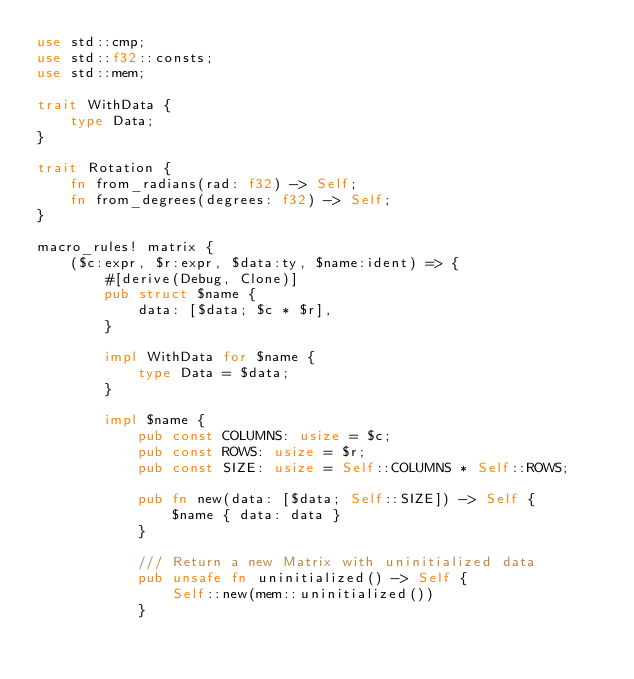<code> <loc_0><loc_0><loc_500><loc_500><_Rust_>use std::cmp;
use std::f32::consts;
use std::mem;

trait WithData {
    type Data;
}

trait Rotation {
    fn from_radians(rad: f32) -> Self;
    fn from_degrees(degrees: f32) -> Self;
}

macro_rules! matrix {
    ($c:expr, $r:expr, $data:ty, $name:ident) => {
        #[derive(Debug, Clone)]
        pub struct $name {
            data: [$data; $c * $r],
        }

        impl WithData for $name {
            type Data = $data;
        }

        impl $name {
            pub const COLUMNS: usize = $c;
            pub const ROWS: usize = $r;
            pub const SIZE: usize = Self::COLUMNS * Self::ROWS;

            pub fn new(data: [$data; Self::SIZE]) -> Self {
                $name { data: data }
            }

            /// Return a new Matrix with uninitialized data
            pub unsafe fn uninitialized() -> Self {
                Self::new(mem::uninitialized())
            }
</code> 